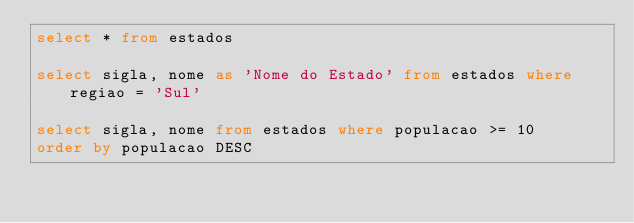Convert code to text. <code><loc_0><loc_0><loc_500><loc_500><_SQL_>select * from estados

select sigla, nome as 'Nome do Estado' from estados where regiao = 'Sul'

select sigla, nome from estados where populacao >= 10 
order by populacao DESC</code> 